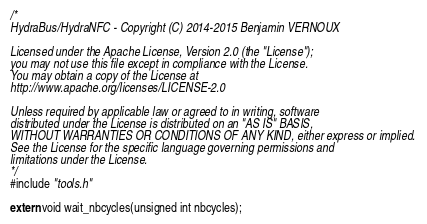<code> <loc_0><loc_0><loc_500><loc_500><_C_>/*
HydraBus/HydraNFC - Copyright (C) 2014-2015 Benjamin VERNOUX

Licensed under the Apache License, Version 2.0 (the "License");
you may not use this file except in compliance with the License.
You may obtain a copy of the License at
http://www.apache.org/licenses/LICENSE-2.0

Unless required by applicable law or agreed to in writing, software
distributed under the License is distributed on an "AS IS" BASIS,
WITHOUT WARRANTIES OR CONDITIONS OF ANY KIND, either express or implied.
See the License for the specific language governing permissions and
limitations under the License.
*/
#include "tools.h"

extern void wait_nbcycles(unsigned int nbcycles);
</code> 